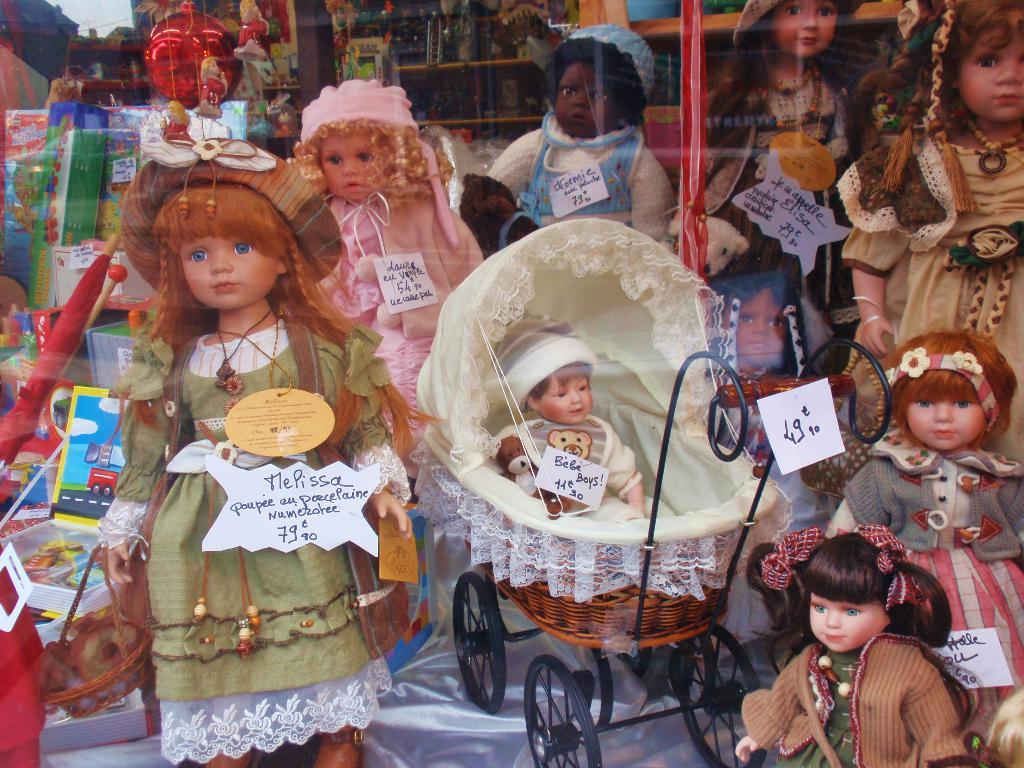What type of toys are in the image? There are Barbie toys in the image. How are the Barbie toys dressed? The Barbie toys are in different colorful dresses. What accessibility device is present in the image? There is a wheelchair in the image. What type of containers can be seen in the image? There are boxes in the image. What type of protection from the rain is present in the image? There is an umbrella in the image. What type of storage or display furniture is present in the image? There are racks in the image. What type of promotional materials are present in the image? There are banners in the image. What other products can be seen in the image? There are other products in the image. How many dogs are sitting on the boxes in the image? There are no dogs present in the image. What type of jar is being used to store the Barbie toys in the image? There is no jar present in the image; the toys are displayed on racks and in boxes. 